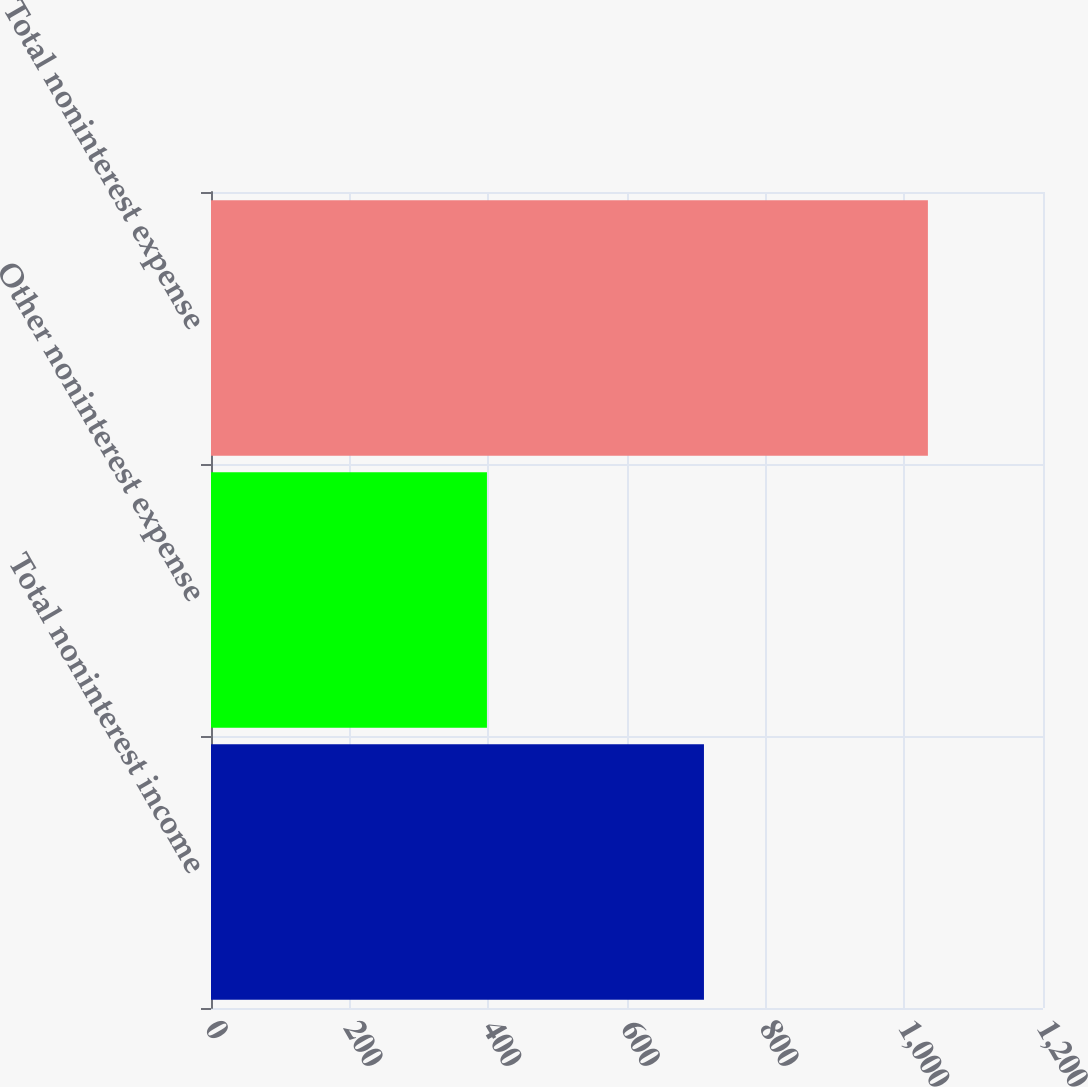<chart> <loc_0><loc_0><loc_500><loc_500><bar_chart><fcel>Total noninterest income<fcel>Other noninterest expense<fcel>Total noninterest expense<nl><fcel>711<fcel>398<fcel>1034<nl></chart> 